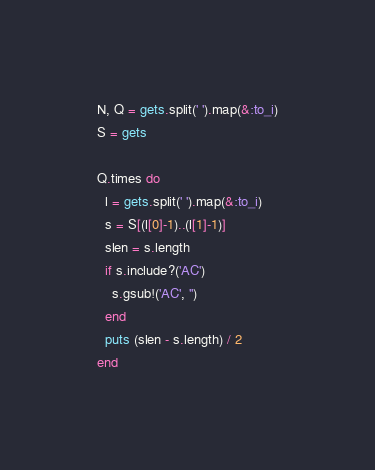Convert code to text. <code><loc_0><loc_0><loc_500><loc_500><_Ruby_>N, Q = gets.split(' ').map(&:to_i)
S = gets

Q.times do
  l = gets.split(' ').map(&:to_i)
  s = S[(l[0]-1)..(l[1]-1)]
  slen = s.length
  if s.include?('AC')
    s.gsub!('AC', '')
  end
  puts (slen - s.length) / 2
end
</code> 